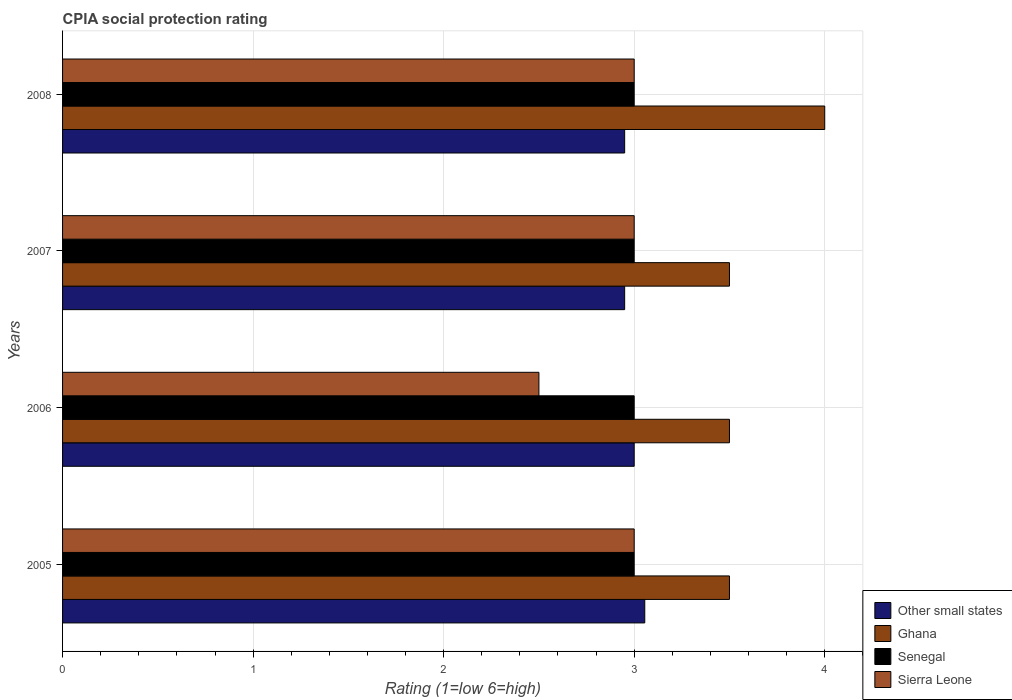How many different coloured bars are there?
Make the answer very short. 4. How many bars are there on the 2nd tick from the top?
Your response must be concise. 4. In how many cases, is the number of bars for a given year not equal to the number of legend labels?
Give a very brief answer. 0. What is the CPIA rating in Sierra Leone in 2007?
Offer a terse response. 3. Across all years, what is the maximum CPIA rating in Senegal?
Offer a very short reply. 3. Across all years, what is the minimum CPIA rating in Other small states?
Offer a terse response. 2.95. In which year was the CPIA rating in Senegal minimum?
Make the answer very short. 2005. What is the difference between the CPIA rating in Other small states in 2005 and that in 2007?
Make the answer very short. 0.11. What is the average CPIA rating in Other small states per year?
Offer a terse response. 2.99. In the year 2007, what is the difference between the CPIA rating in Ghana and CPIA rating in Senegal?
Your answer should be compact. 0.5. What is the ratio of the CPIA rating in Senegal in 2005 to that in 2007?
Your answer should be very brief. 1. Is the CPIA rating in Other small states in 2006 less than that in 2008?
Provide a short and direct response. No. Is the difference between the CPIA rating in Ghana in 2006 and 2008 greater than the difference between the CPIA rating in Senegal in 2006 and 2008?
Your answer should be very brief. No. What is the difference between the highest and the lowest CPIA rating in Senegal?
Your answer should be compact. 0. In how many years, is the CPIA rating in Senegal greater than the average CPIA rating in Senegal taken over all years?
Provide a succinct answer. 0. Is the sum of the CPIA rating in Senegal in 2005 and 2007 greater than the maximum CPIA rating in Sierra Leone across all years?
Provide a short and direct response. Yes. What does the 1st bar from the top in 2006 represents?
Give a very brief answer. Sierra Leone. What does the 2nd bar from the bottom in 2005 represents?
Give a very brief answer. Ghana. Is it the case that in every year, the sum of the CPIA rating in Other small states and CPIA rating in Ghana is greater than the CPIA rating in Senegal?
Offer a terse response. Yes. Does the graph contain any zero values?
Make the answer very short. No. Does the graph contain grids?
Keep it short and to the point. Yes. Where does the legend appear in the graph?
Offer a terse response. Bottom right. How are the legend labels stacked?
Offer a terse response. Vertical. What is the title of the graph?
Your answer should be compact. CPIA social protection rating. Does "Philippines" appear as one of the legend labels in the graph?
Give a very brief answer. No. What is the label or title of the Y-axis?
Give a very brief answer. Years. What is the Rating (1=low 6=high) of Other small states in 2005?
Your response must be concise. 3.06. What is the Rating (1=low 6=high) in Ghana in 2005?
Offer a very short reply. 3.5. What is the Rating (1=low 6=high) in Senegal in 2005?
Provide a short and direct response. 3. What is the Rating (1=low 6=high) in Other small states in 2006?
Your response must be concise. 3. What is the Rating (1=low 6=high) in Ghana in 2006?
Make the answer very short. 3.5. What is the Rating (1=low 6=high) of Senegal in 2006?
Your answer should be compact. 3. What is the Rating (1=low 6=high) of Sierra Leone in 2006?
Provide a succinct answer. 2.5. What is the Rating (1=low 6=high) of Other small states in 2007?
Your answer should be very brief. 2.95. What is the Rating (1=low 6=high) in Senegal in 2007?
Your response must be concise. 3. What is the Rating (1=low 6=high) of Sierra Leone in 2007?
Offer a terse response. 3. What is the Rating (1=low 6=high) in Other small states in 2008?
Your answer should be compact. 2.95. What is the Rating (1=low 6=high) in Senegal in 2008?
Keep it short and to the point. 3. What is the Rating (1=low 6=high) in Sierra Leone in 2008?
Offer a very short reply. 3. Across all years, what is the maximum Rating (1=low 6=high) in Other small states?
Your answer should be very brief. 3.06. Across all years, what is the maximum Rating (1=low 6=high) of Ghana?
Provide a short and direct response. 4. Across all years, what is the maximum Rating (1=low 6=high) in Sierra Leone?
Provide a succinct answer. 3. Across all years, what is the minimum Rating (1=low 6=high) in Other small states?
Your answer should be very brief. 2.95. Across all years, what is the minimum Rating (1=low 6=high) in Senegal?
Ensure brevity in your answer.  3. What is the total Rating (1=low 6=high) in Other small states in the graph?
Give a very brief answer. 11.96. What is the total Rating (1=low 6=high) in Senegal in the graph?
Your answer should be very brief. 12. What is the total Rating (1=low 6=high) in Sierra Leone in the graph?
Your answer should be very brief. 11.5. What is the difference between the Rating (1=low 6=high) of Other small states in 2005 and that in 2006?
Make the answer very short. 0.06. What is the difference between the Rating (1=low 6=high) of Ghana in 2005 and that in 2006?
Make the answer very short. 0. What is the difference between the Rating (1=low 6=high) in Senegal in 2005 and that in 2006?
Your response must be concise. 0. What is the difference between the Rating (1=low 6=high) of Sierra Leone in 2005 and that in 2006?
Give a very brief answer. 0.5. What is the difference between the Rating (1=low 6=high) of Other small states in 2005 and that in 2007?
Offer a terse response. 0.11. What is the difference between the Rating (1=low 6=high) of Ghana in 2005 and that in 2007?
Offer a terse response. 0. What is the difference between the Rating (1=low 6=high) of Other small states in 2005 and that in 2008?
Offer a terse response. 0.11. What is the difference between the Rating (1=low 6=high) of Sierra Leone in 2005 and that in 2008?
Give a very brief answer. 0. What is the difference between the Rating (1=low 6=high) in Ghana in 2006 and that in 2007?
Provide a short and direct response. 0. What is the difference between the Rating (1=low 6=high) in Sierra Leone in 2006 and that in 2007?
Provide a short and direct response. -0.5. What is the difference between the Rating (1=low 6=high) of Ghana in 2006 and that in 2008?
Your answer should be very brief. -0.5. What is the difference between the Rating (1=low 6=high) in Senegal in 2006 and that in 2008?
Provide a short and direct response. 0. What is the difference between the Rating (1=low 6=high) in Sierra Leone in 2006 and that in 2008?
Make the answer very short. -0.5. What is the difference between the Rating (1=low 6=high) of Sierra Leone in 2007 and that in 2008?
Provide a short and direct response. 0. What is the difference between the Rating (1=low 6=high) of Other small states in 2005 and the Rating (1=low 6=high) of Ghana in 2006?
Your response must be concise. -0.44. What is the difference between the Rating (1=low 6=high) of Other small states in 2005 and the Rating (1=low 6=high) of Senegal in 2006?
Your response must be concise. 0.06. What is the difference between the Rating (1=low 6=high) in Other small states in 2005 and the Rating (1=low 6=high) in Sierra Leone in 2006?
Give a very brief answer. 0.56. What is the difference between the Rating (1=low 6=high) of Ghana in 2005 and the Rating (1=low 6=high) of Senegal in 2006?
Keep it short and to the point. 0.5. What is the difference between the Rating (1=low 6=high) in Ghana in 2005 and the Rating (1=low 6=high) in Sierra Leone in 2006?
Provide a short and direct response. 1. What is the difference between the Rating (1=low 6=high) of Senegal in 2005 and the Rating (1=low 6=high) of Sierra Leone in 2006?
Make the answer very short. 0.5. What is the difference between the Rating (1=low 6=high) in Other small states in 2005 and the Rating (1=low 6=high) in Ghana in 2007?
Your response must be concise. -0.44. What is the difference between the Rating (1=low 6=high) in Other small states in 2005 and the Rating (1=low 6=high) in Senegal in 2007?
Your answer should be compact. 0.06. What is the difference between the Rating (1=low 6=high) of Other small states in 2005 and the Rating (1=low 6=high) of Sierra Leone in 2007?
Make the answer very short. 0.06. What is the difference between the Rating (1=low 6=high) of Ghana in 2005 and the Rating (1=low 6=high) of Senegal in 2007?
Ensure brevity in your answer.  0.5. What is the difference between the Rating (1=low 6=high) in Senegal in 2005 and the Rating (1=low 6=high) in Sierra Leone in 2007?
Your response must be concise. 0. What is the difference between the Rating (1=low 6=high) of Other small states in 2005 and the Rating (1=low 6=high) of Ghana in 2008?
Your answer should be very brief. -0.94. What is the difference between the Rating (1=low 6=high) of Other small states in 2005 and the Rating (1=low 6=high) of Senegal in 2008?
Keep it short and to the point. 0.06. What is the difference between the Rating (1=low 6=high) of Other small states in 2005 and the Rating (1=low 6=high) of Sierra Leone in 2008?
Keep it short and to the point. 0.06. What is the difference between the Rating (1=low 6=high) of Ghana in 2005 and the Rating (1=low 6=high) of Senegal in 2008?
Keep it short and to the point. 0.5. What is the difference between the Rating (1=low 6=high) of Ghana in 2005 and the Rating (1=low 6=high) of Sierra Leone in 2008?
Keep it short and to the point. 0.5. What is the difference between the Rating (1=low 6=high) in Other small states in 2006 and the Rating (1=low 6=high) in Ghana in 2007?
Your answer should be compact. -0.5. What is the difference between the Rating (1=low 6=high) in Other small states in 2006 and the Rating (1=low 6=high) in Senegal in 2007?
Offer a terse response. 0. What is the difference between the Rating (1=low 6=high) of Other small states in 2006 and the Rating (1=low 6=high) of Sierra Leone in 2007?
Make the answer very short. 0. What is the difference between the Rating (1=low 6=high) of Ghana in 2006 and the Rating (1=low 6=high) of Sierra Leone in 2007?
Make the answer very short. 0.5. What is the difference between the Rating (1=low 6=high) of Senegal in 2006 and the Rating (1=low 6=high) of Sierra Leone in 2007?
Offer a terse response. 0. What is the difference between the Rating (1=low 6=high) of Ghana in 2006 and the Rating (1=low 6=high) of Sierra Leone in 2008?
Offer a very short reply. 0.5. What is the difference between the Rating (1=low 6=high) of Senegal in 2006 and the Rating (1=low 6=high) of Sierra Leone in 2008?
Ensure brevity in your answer.  0. What is the difference between the Rating (1=low 6=high) of Other small states in 2007 and the Rating (1=low 6=high) of Ghana in 2008?
Provide a short and direct response. -1.05. What is the difference between the Rating (1=low 6=high) in Other small states in 2007 and the Rating (1=low 6=high) in Senegal in 2008?
Your answer should be very brief. -0.05. What is the difference between the Rating (1=low 6=high) of Ghana in 2007 and the Rating (1=low 6=high) of Senegal in 2008?
Keep it short and to the point. 0.5. What is the average Rating (1=low 6=high) of Other small states per year?
Provide a short and direct response. 2.99. What is the average Rating (1=low 6=high) in Ghana per year?
Provide a succinct answer. 3.62. What is the average Rating (1=low 6=high) of Senegal per year?
Make the answer very short. 3. What is the average Rating (1=low 6=high) in Sierra Leone per year?
Offer a very short reply. 2.88. In the year 2005, what is the difference between the Rating (1=low 6=high) in Other small states and Rating (1=low 6=high) in Ghana?
Offer a very short reply. -0.44. In the year 2005, what is the difference between the Rating (1=low 6=high) in Other small states and Rating (1=low 6=high) in Senegal?
Ensure brevity in your answer.  0.06. In the year 2005, what is the difference between the Rating (1=low 6=high) of Other small states and Rating (1=low 6=high) of Sierra Leone?
Ensure brevity in your answer.  0.06. In the year 2005, what is the difference between the Rating (1=low 6=high) in Ghana and Rating (1=low 6=high) in Sierra Leone?
Offer a very short reply. 0.5. In the year 2006, what is the difference between the Rating (1=low 6=high) of Other small states and Rating (1=low 6=high) of Ghana?
Your answer should be compact. -0.5. In the year 2006, what is the difference between the Rating (1=low 6=high) in Other small states and Rating (1=low 6=high) in Senegal?
Provide a short and direct response. 0. In the year 2006, what is the difference between the Rating (1=low 6=high) in Senegal and Rating (1=low 6=high) in Sierra Leone?
Your response must be concise. 0.5. In the year 2007, what is the difference between the Rating (1=low 6=high) of Other small states and Rating (1=low 6=high) of Ghana?
Keep it short and to the point. -0.55. In the year 2007, what is the difference between the Rating (1=low 6=high) of Other small states and Rating (1=low 6=high) of Senegal?
Make the answer very short. -0.05. In the year 2007, what is the difference between the Rating (1=low 6=high) of Other small states and Rating (1=low 6=high) of Sierra Leone?
Offer a terse response. -0.05. In the year 2007, what is the difference between the Rating (1=low 6=high) in Ghana and Rating (1=low 6=high) in Senegal?
Offer a very short reply. 0.5. In the year 2008, what is the difference between the Rating (1=low 6=high) in Other small states and Rating (1=low 6=high) in Ghana?
Provide a succinct answer. -1.05. In the year 2008, what is the difference between the Rating (1=low 6=high) in Senegal and Rating (1=low 6=high) in Sierra Leone?
Keep it short and to the point. 0. What is the ratio of the Rating (1=low 6=high) in Other small states in 2005 to that in 2006?
Your answer should be very brief. 1.02. What is the ratio of the Rating (1=low 6=high) in Ghana in 2005 to that in 2006?
Your response must be concise. 1. What is the ratio of the Rating (1=low 6=high) in Senegal in 2005 to that in 2006?
Ensure brevity in your answer.  1. What is the ratio of the Rating (1=low 6=high) in Other small states in 2005 to that in 2007?
Provide a succinct answer. 1.04. What is the ratio of the Rating (1=low 6=high) in Ghana in 2005 to that in 2007?
Your answer should be compact. 1. What is the ratio of the Rating (1=low 6=high) of Senegal in 2005 to that in 2007?
Provide a succinct answer. 1. What is the ratio of the Rating (1=low 6=high) of Sierra Leone in 2005 to that in 2007?
Your answer should be compact. 1. What is the ratio of the Rating (1=low 6=high) of Other small states in 2005 to that in 2008?
Your answer should be very brief. 1.04. What is the ratio of the Rating (1=low 6=high) of Sierra Leone in 2005 to that in 2008?
Ensure brevity in your answer.  1. What is the ratio of the Rating (1=low 6=high) in Other small states in 2006 to that in 2007?
Offer a very short reply. 1.02. What is the ratio of the Rating (1=low 6=high) of Senegal in 2006 to that in 2007?
Make the answer very short. 1. What is the ratio of the Rating (1=low 6=high) of Sierra Leone in 2006 to that in 2007?
Offer a very short reply. 0.83. What is the ratio of the Rating (1=low 6=high) in Other small states in 2006 to that in 2008?
Offer a terse response. 1.02. What is the ratio of the Rating (1=low 6=high) in Ghana in 2006 to that in 2008?
Make the answer very short. 0.88. What is the ratio of the Rating (1=low 6=high) of Senegal in 2006 to that in 2008?
Provide a succinct answer. 1. What is the ratio of the Rating (1=low 6=high) of Other small states in 2007 to that in 2008?
Make the answer very short. 1. What is the difference between the highest and the second highest Rating (1=low 6=high) in Other small states?
Keep it short and to the point. 0.06. What is the difference between the highest and the second highest Rating (1=low 6=high) of Ghana?
Your answer should be very brief. 0.5. What is the difference between the highest and the second highest Rating (1=low 6=high) of Sierra Leone?
Your answer should be very brief. 0. What is the difference between the highest and the lowest Rating (1=low 6=high) of Other small states?
Give a very brief answer. 0.11. What is the difference between the highest and the lowest Rating (1=low 6=high) of Senegal?
Offer a terse response. 0. 